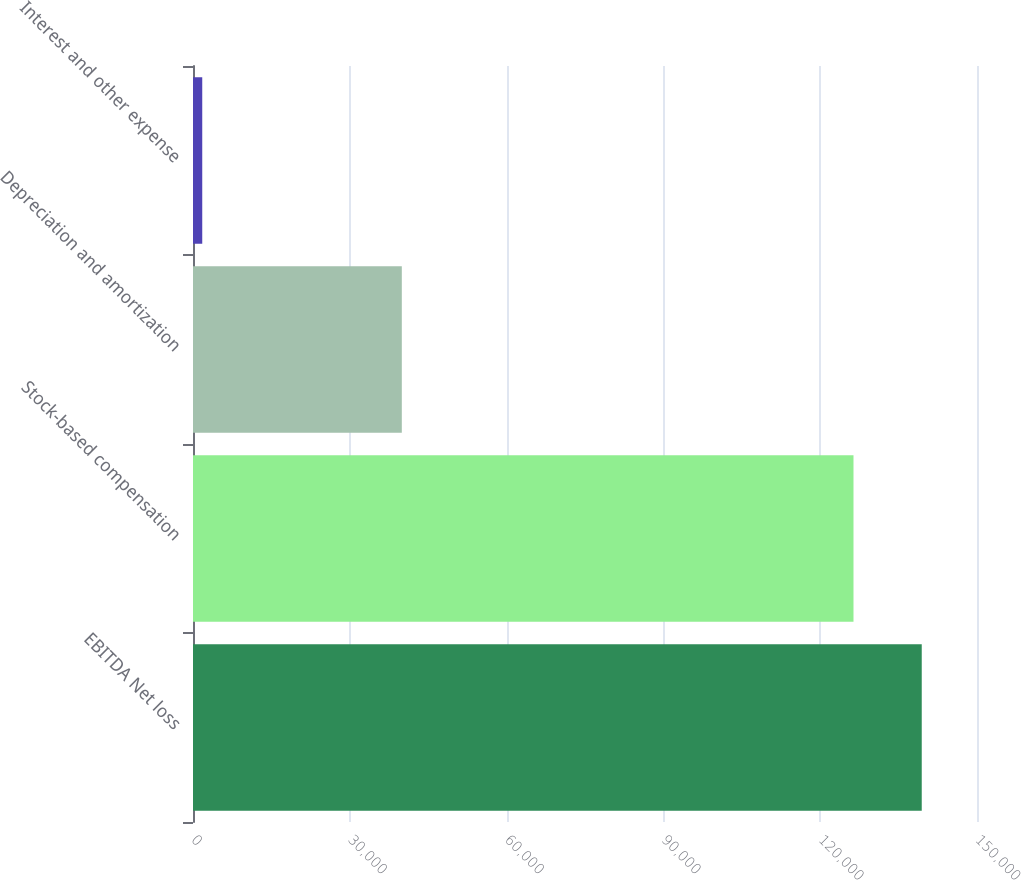Convert chart. <chart><loc_0><loc_0><loc_500><loc_500><bar_chart><fcel>EBITDA Net loss<fcel>Stock-based compensation<fcel>Depreciation and amortization<fcel>Interest and other expense<nl><fcel>139428<fcel>126369<fcel>39951<fcel>1769<nl></chart> 